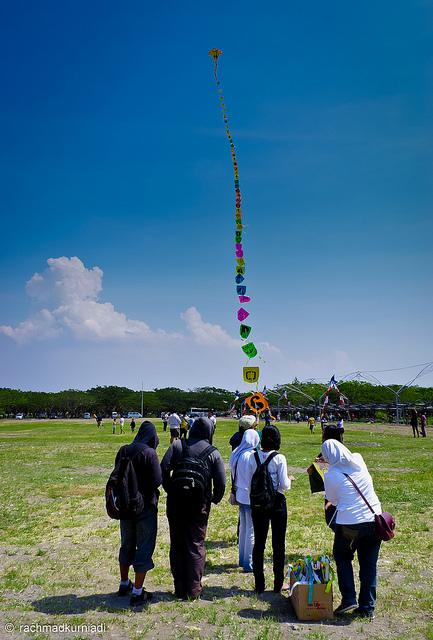Is this a normal kite?
Concise answer only. No. What color is the girls top?
Write a very short answer. White. Are these adults flying the kite?
Give a very brief answer. Yes. Are the kites going to run away?
Quick response, please. No. 